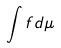<formula> <loc_0><loc_0><loc_500><loc_500>\int f d \mu</formula> 